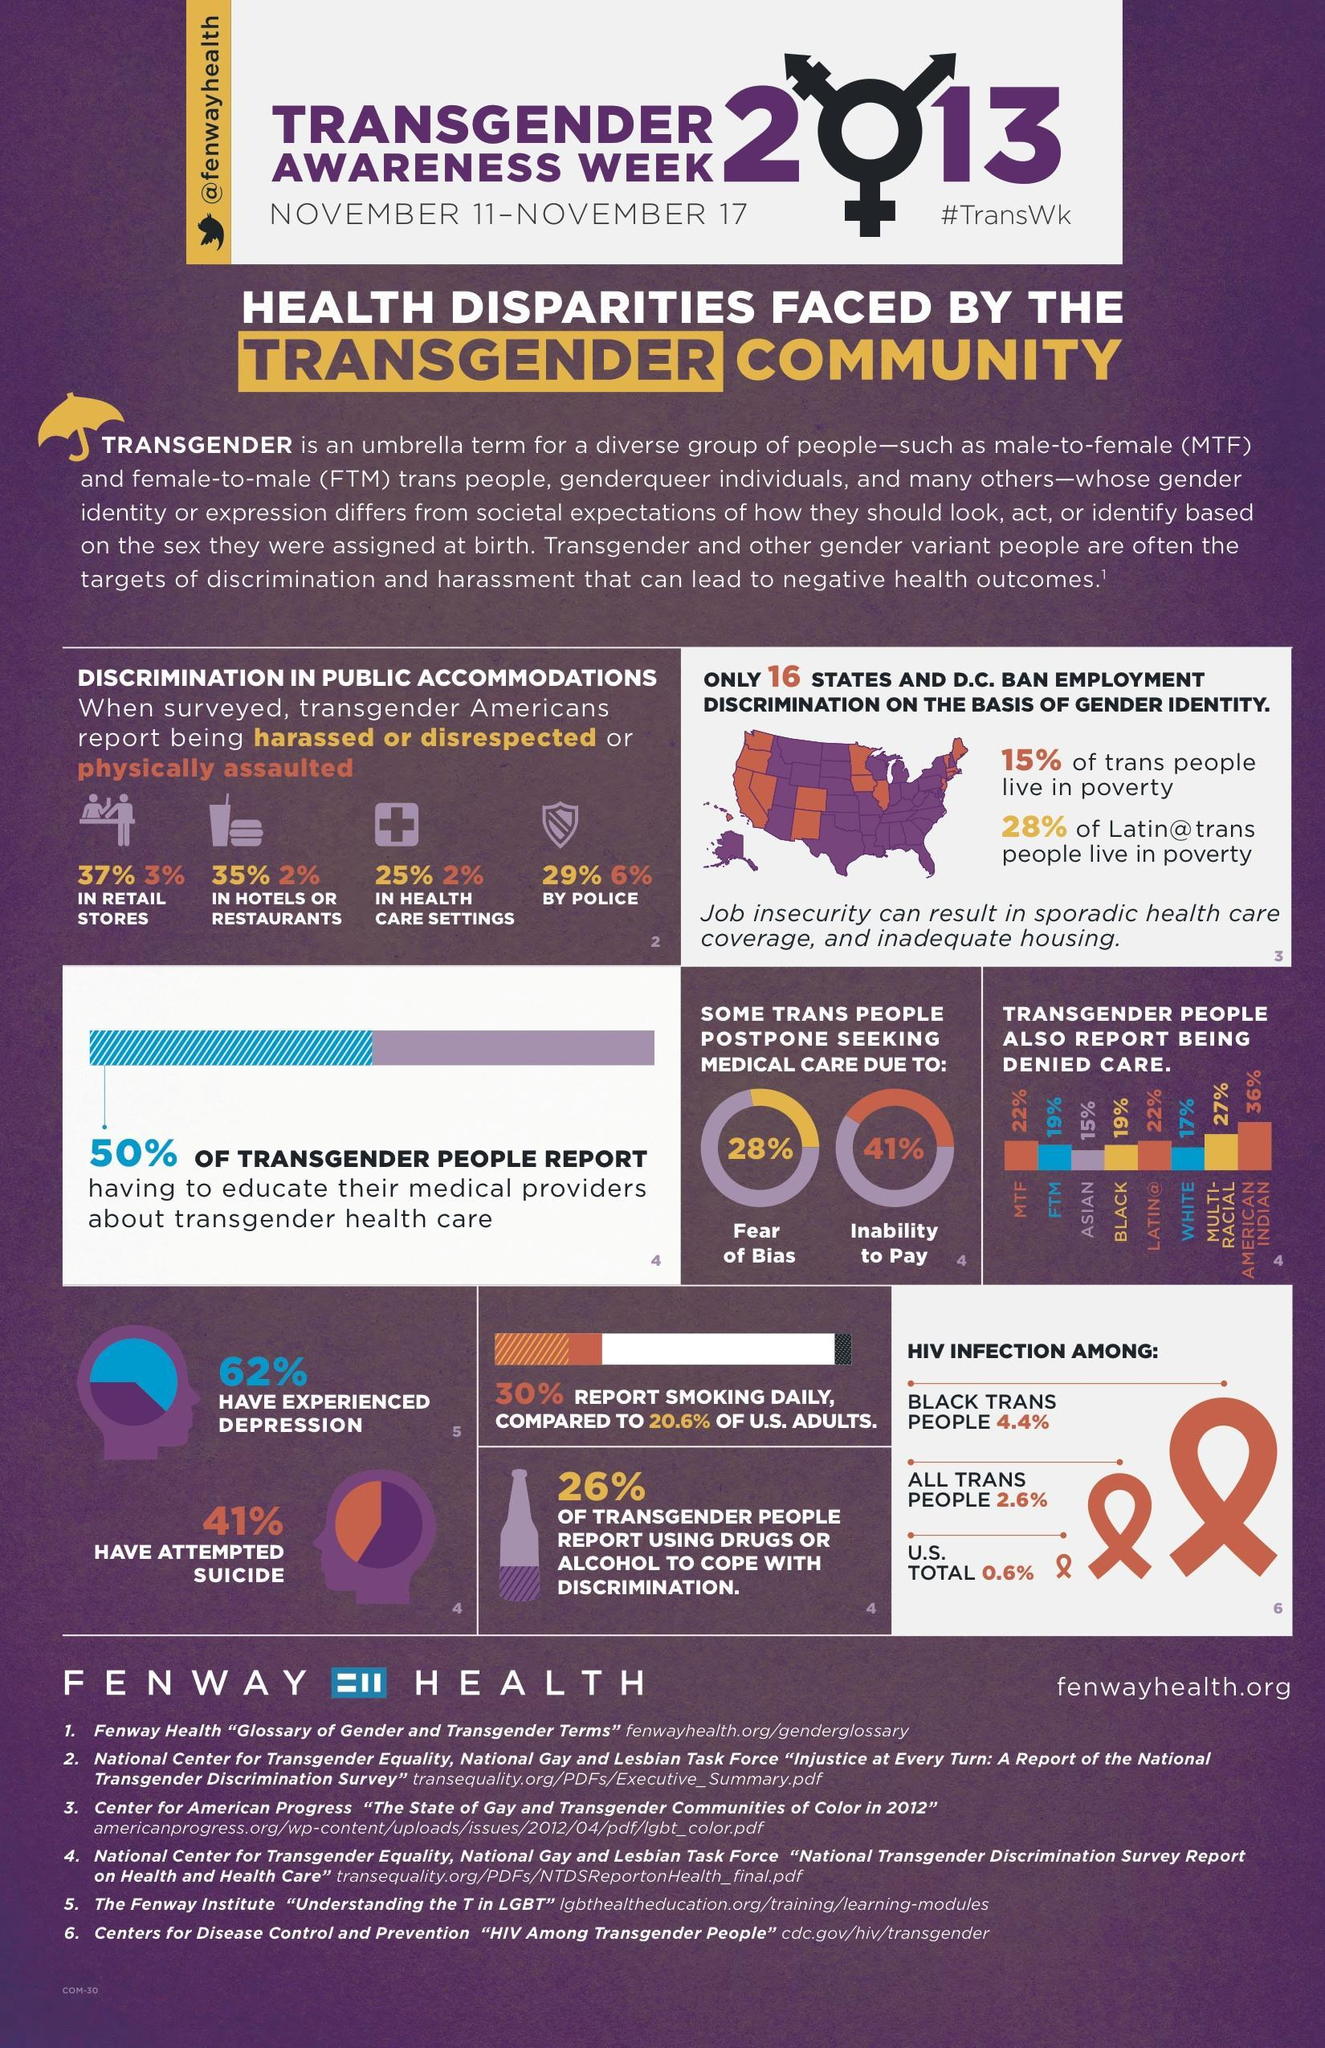how many have been physically assaulted in retail stores
Answer the question with a short phrase. 3% how many have been physically assaulted by police 6% what is the percentage difference in daily smoking between US adults and transgenders 9.4 how many postpone medical care due to inability to pay 41% 